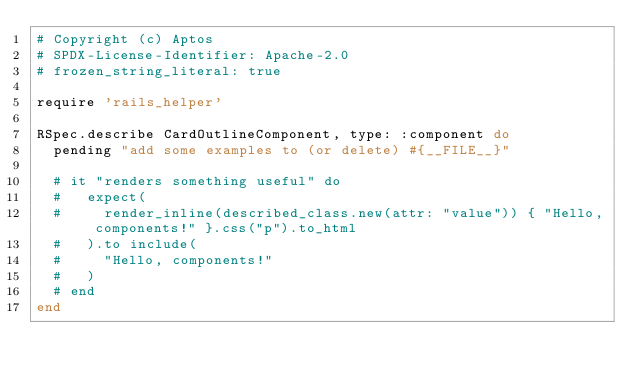Convert code to text. <code><loc_0><loc_0><loc_500><loc_500><_Ruby_># Copyright (c) Aptos
# SPDX-License-Identifier: Apache-2.0
# frozen_string_literal: true

require 'rails_helper'

RSpec.describe CardOutlineComponent, type: :component do
  pending "add some examples to (or delete) #{__FILE__}"

  # it "renders something useful" do
  #   expect(
  #     render_inline(described_class.new(attr: "value")) { "Hello, components!" }.css("p").to_html
  #   ).to include(
  #     "Hello, components!"
  #   )
  # end
end
</code> 